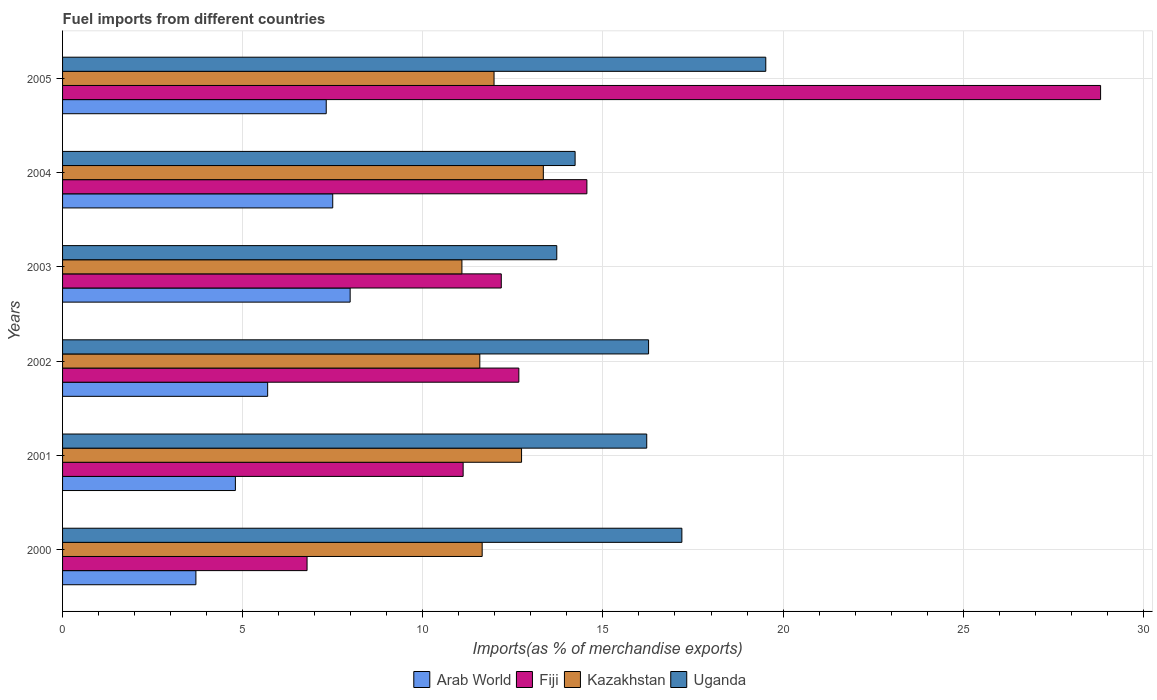How many bars are there on the 6th tick from the top?
Make the answer very short. 4. In how many cases, is the number of bars for a given year not equal to the number of legend labels?
Give a very brief answer. 0. What is the percentage of imports to different countries in Kazakhstan in 2002?
Give a very brief answer. 11.58. Across all years, what is the maximum percentage of imports to different countries in Uganda?
Your response must be concise. 19.52. Across all years, what is the minimum percentage of imports to different countries in Kazakhstan?
Make the answer very short. 11.09. In which year was the percentage of imports to different countries in Fiji maximum?
Make the answer very short. 2005. What is the total percentage of imports to different countries in Fiji in the graph?
Provide a succinct answer. 86.12. What is the difference between the percentage of imports to different countries in Arab World in 2000 and that in 2002?
Offer a terse response. -1.99. What is the difference between the percentage of imports to different countries in Uganda in 2004 and the percentage of imports to different countries in Kazakhstan in 2003?
Provide a succinct answer. 3.14. What is the average percentage of imports to different countries in Fiji per year?
Make the answer very short. 14.35. In the year 2004, what is the difference between the percentage of imports to different countries in Fiji and percentage of imports to different countries in Arab World?
Provide a short and direct response. 7.05. In how many years, is the percentage of imports to different countries in Kazakhstan greater than 19 %?
Your answer should be compact. 0. What is the ratio of the percentage of imports to different countries in Fiji in 2001 to that in 2003?
Provide a succinct answer. 0.91. Is the percentage of imports to different countries in Uganda in 2001 less than that in 2005?
Keep it short and to the point. Yes. Is the difference between the percentage of imports to different countries in Fiji in 2003 and 2004 greater than the difference between the percentage of imports to different countries in Arab World in 2003 and 2004?
Ensure brevity in your answer.  No. What is the difference between the highest and the second highest percentage of imports to different countries in Fiji?
Offer a terse response. 14.26. What is the difference between the highest and the lowest percentage of imports to different countries in Arab World?
Your answer should be compact. 4.28. In how many years, is the percentage of imports to different countries in Uganda greater than the average percentage of imports to different countries in Uganda taken over all years?
Provide a short and direct response. 4. Is the sum of the percentage of imports to different countries in Kazakhstan in 2000 and 2001 greater than the maximum percentage of imports to different countries in Arab World across all years?
Your answer should be very brief. Yes. Is it the case that in every year, the sum of the percentage of imports to different countries in Uganda and percentage of imports to different countries in Fiji is greater than the sum of percentage of imports to different countries in Arab World and percentage of imports to different countries in Kazakhstan?
Keep it short and to the point. Yes. What does the 1st bar from the top in 2005 represents?
Your answer should be compact. Uganda. What does the 2nd bar from the bottom in 2003 represents?
Your answer should be compact. Fiji. Is it the case that in every year, the sum of the percentage of imports to different countries in Fiji and percentage of imports to different countries in Uganda is greater than the percentage of imports to different countries in Arab World?
Your response must be concise. Yes. What is the difference between two consecutive major ticks on the X-axis?
Provide a succinct answer. 5. Are the values on the major ticks of X-axis written in scientific E-notation?
Your response must be concise. No. Does the graph contain any zero values?
Give a very brief answer. No. Does the graph contain grids?
Ensure brevity in your answer.  Yes. How many legend labels are there?
Provide a short and direct response. 4. What is the title of the graph?
Provide a succinct answer. Fuel imports from different countries. Does "Dominica" appear as one of the legend labels in the graph?
Provide a short and direct response. No. What is the label or title of the X-axis?
Ensure brevity in your answer.  Imports(as % of merchandise exports). What is the Imports(as % of merchandise exports) of Arab World in 2000?
Give a very brief answer. 3.7. What is the Imports(as % of merchandise exports) of Fiji in 2000?
Offer a terse response. 6.79. What is the Imports(as % of merchandise exports) of Kazakhstan in 2000?
Make the answer very short. 11.65. What is the Imports(as % of merchandise exports) in Uganda in 2000?
Your answer should be compact. 17.19. What is the Imports(as % of merchandise exports) in Arab World in 2001?
Your answer should be compact. 4.8. What is the Imports(as % of merchandise exports) in Fiji in 2001?
Offer a terse response. 11.12. What is the Imports(as % of merchandise exports) in Kazakhstan in 2001?
Provide a short and direct response. 12.74. What is the Imports(as % of merchandise exports) in Uganda in 2001?
Your response must be concise. 16.22. What is the Imports(as % of merchandise exports) of Arab World in 2002?
Your answer should be compact. 5.69. What is the Imports(as % of merchandise exports) in Fiji in 2002?
Ensure brevity in your answer.  12.67. What is the Imports(as % of merchandise exports) of Kazakhstan in 2002?
Provide a short and direct response. 11.58. What is the Imports(as % of merchandise exports) of Uganda in 2002?
Offer a very short reply. 16.27. What is the Imports(as % of merchandise exports) in Arab World in 2003?
Give a very brief answer. 7.98. What is the Imports(as % of merchandise exports) in Fiji in 2003?
Give a very brief answer. 12.18. What is the Imports(as % of merchandise exports) in Kazakhstan in 2003?
Provide a succinct answer. 11.09. What is the Imports(as % of merchandise exports) of Uganda in 2003?
Your answer should be very brief. 13.72. What is the Imports(as % of merchandise exports) of Arab World in 2004?
Keep it short and to the point. 7.5. What is the Imports(as % of merchandise exports) in Fiji in 2004?
Provide a short and direct response. 14.55. What is the Imports(as % of merchandise exports) of Kazakhstan in 2004?
Your response must be concise. 13.35. What is the Imports(as % of merchandise exports) of Uganda in 2004?
Make the answer very short. 14.23. What is the Imports(as % of merchandise exports) in Arab World in 2005?
Ensure brevity in your answer.  7.32. What is the Imports(as % of merchandise exports) in Fiji in 2005?
Your response must be concise. 28.81. What is the Imports(as % of merchandise exports) in Kazakhstan in 2005?
Give a very brief answer. 11.98. What is the Imports(as % of merchandise exports) in Uganda in 2005?
Provide a succinct answer. 19.52. Across all years, what is the maximum Imports(as % of merchandise exports) in Arab World?
Your response must be concise. 7.98. Across all years, what is the maximum Imports(as % of merchandise exports) of Fiji?
Your response must be concise. 28.81. Across all years, what is the maximum Imports(as % of merchandise exports) in Kazakhstan?
Provide a succinct answer. 13.35. Across all years, what is the maximum Imports(as % of merchandise exports) in Uganda?
Your response must be concise. 19.52. Across all years, what is the minimum Imports(as % of merchandise exports) in Arab World?
Keep it short and to the point. 3.7. Across all years, what is the minimum Imports(as % of merchandise exports) in Fiji?
Make the answer very short. 6.79. Across all years, what is the minimum Imports(as % of merchandise exports) in Kazakhstan?
Give a very brief answer. 11.09. Across all years, what is the minimum Imports(as % of merchandise exports) of Uganda?
Provide a short and direct response. 13.72. What is the total Imports(as % of merchandise exports) of Arab World in the graph?
Provide a short and direct response. 36.99. What is the total Imports(as % of merchandise exports) of Fiji in the graph?
Provide a short and direct response. 86.12. What is the total Imports(as % of merchandise exports) in Kazakhstan in the graph?
Offer a terse response. 72.38. What is the total Imports(as % of merchandise exports) of Uganda in the graph?
Keep it short and to the point. 97.14. What is the difference between the Imports(as % of merchandise exports) in Arab World in 2000 and that in 2001?
Give a very brief answer. -1.1. What is the difference between the Imports(as % of merchandise exports) of Fiji in 2000 and that in 2001?
Keep it short and to the point. -4.33. What is the difference between the Imports(as % of merchandise exports) of Kazakhstan in 2000 and that in 2001?
Provide a short and direct response. -1.09. What is the difference between the Imports(as % of merchandise exports) in Uganda in 2000 and that in 2001?
Your response must be concise. 0.98. What is the difference between the Imports(as % of merchandise exports) in Arab World in 2000 and that in 2002?
Your answer should be compact. -1.99. What is the difference between the Imports(as % of merchandise exports) of Fiji in 2000 and that in 2002?
Your answer should be compact. -5.88. What is the difference between the Imports(as % of merchandise exports) in Kazakhstan in 2000 and that in 2002?
Your answer should be very brief. 0.07. What is the difference between the Imports(as % of merchandise exports) in Uganda in 2000 and that in 2002?
Provide a succinct answer. 0.92. What is the difference between the Imports(as % of merchandise exports) of Arab World in 2000 and that in 2003?
Keep it short and to the point. -4.28. What is the difference between the Imports(as % of merchandise exports) of Fiji in 2000 and that in 2003?
Your answer should be compact. -5.39. What is the difference between the Imports(as % of merchandise exports) of Kazakhstan in 2000 and that in 2003?
Your answer should be compact. 0.56. What is the difference between the Imports(as % of merchandise exports) in Uganda in 2000 and that in 2003?
Provide a short and direct response. 3.47. What is the difference between the Imports(as % of merchandise exports) of Arab World in 2000 and that in 2004?
Ensure brevity in your answer.  -3.8. What is the difference between the Imports(as % of merchandise exports) in Fiji in 2000 and that in 2004?
Your response must be concise. -7.77. What is the difference between the Imports(as % of merchandise exports) in Kazakhstan in 2000 and that in 2004?
Provide a succinct answer. -1.7. What is the difference between the Imports(as % of merchandise exports) in Uganda in 2000 and that in 2004?
Your answer should be compact. 2.96. What is the difference between the Imports(as % of merchandise exports) of Arab World in 2000 and that in 2005?
Offer a terse response. -3.62. What is the difference between the Imports(as % of merchandise exports) in Fiji in 2000 and that in 2005?
Provide a succinct answer. -22.03. What is the difference between the Imports(as % of merchandise exports) in Kazakhstan in 2000 and that in 2005?
Your answer should be very brief. -0.33. What is the difference between the Imports(as % of merchandise exports) of Uganda in 2000 and that in 2005?
Offer a very short reply. -2.33. What is the difference between the Imports(as % of merchandise exports) of Arab World in 2001 and that in 2002?
Offer a terse response. -0.9. What is the difference between the Imports(as % of merchandise exports) in Fiji in 2001 and that in 2002?
Provide a succinct answer. -1.55. What is the difference between the Imports(as % of merchandise exports) in Kazakhstan in 2001 and that in 2002?
Keep it short and to the point. 1.16. What is the difference between the Imports(as % of merchandise exports) in Uganda in 2001 and that in 2002?
Your answer should be very brief. -0.05. What is the difference between the Imports(as % of merchandise exports) of Arab World in 2001 and that in 2003?
Offer a very short reply. -3.19. What is the difference between the Imports(as % of merchandise exports) in Fiji in 2001 and that in 2003?
Your answer should be compact. -1.06. What is the difference between the Imports(as % of merchandise exports) in Kazakhstan in 2001 and that in 2003?
Your answer should be very brief. 1.66. What is the difference between the Imports(as % of merchandise exports) in Uganda in 2001 and that in 2003?
Provide a succinct answer. 2.5. What is the difference between the Imports(as % of merchandise exports) in Arab World in 2001 and that in 2004?
Your answer should be compact. -2.7. What is the difference between the Imports(as % of merchandise exports) in Fiji in 2001 and that in 2004?
Your answer should be compact. -3.44. What is the difference between the Imports(as % of merchandise exports) of Kazakhstan in 2001 and that in 2004?
Keep it short and to the point. -0.6. What is the difference between the Imports(as % of merchandise exports) in Uganda in 2001 and that in 2004?
Your answer should be very brief. 1.99. What is the difference between the Imports(as % of merchandise exports) in Arab World in 2001 and that in 2005?
Offer a very short reply. -2.52. What is the difference between the Imports(as % of merchandise exports) in Fiji in 2001 and that in 2005?
Give a very brief answer. -17.69. What is the difference between the Imports(as % of merchandise exports) in Kazakhstan in 2001 and that in 2005?
Your answer should be compact. 0.76. What is the difference between the Imports(as % of merchandise exports) of Uganda in 2001 and that in 2005?
Your answer should be compact. -3.3. What is the difference between the Imports(as % of merchandise exports) of Arab World in 2002 and that in 2003?
Your answer should be very brief. -2.29. What is the difference between the Imports(as % of merchandise exports) of Fiji in 2002 and that in 2003?
Offer a very short reply. 0.49. What is the difference between the Imports(as % of merchandise exports) in Kazakhstan in 2002 and that in 2003?
Ensure brevity in your answer.  0.5. What is the difference between the Imports(as % of merchandise exports) in Uganda in 2002 and that in 2003?
Make the answer very short. 2.55. What is the difference between the Imports(as % of merchandise exports) of Arab World in 2002 and that in 2004?
Your answer should be very brief. -1.81. What is the difference between the Imports(as % of merchandise exports) in Fiji in 2002 and that in 2004?
Your answer should be compact. -1.89. What is the difference between the Imports(as % of merchandise exports) in Kazakhstan in 2002 and that in 2004?
Your response must be concise. -1.76. What is the difference between the Imports(as % of merchandise exports) of Uganda in 2002 and that in 2004?
Provide a succinct answer. 2.04. What is the difference between the Imports(as % of merchandise exports) in Arab World in 2002 and that in 2005?
Offer a terse response. -1.63. What is the difference between the Imports(as % of merchandise exports) in Fiji in 2002 and that in 2005?
Offer a very short reply. -16.15. What is the difference between the Imports(as % of merchandise exports) in Kazakhstan in 2002 and that in 2005?
Provide a succinct answer. -0.4. What is the difference between the Imports(as % of merchandise exports) of Uganda in 2002 and that in 2005?
Your answer should be very brief. -3.25. What is the difference between the Imports(as % of merchandise exports) in Arab World in 2003 and that in 2004?
Your answer should be compact. 0.48. What is the difference between the Imports(as % of merchandise exports) in Fiji in 2003 and that in 2004?
Provide a succinct answer. -2.38. What is the difference between the Imports(as % of merchandise exports) of Kazakhstan in 2003 and that in 2004?
Provide a short and direct response. -2.26. What is the difference between the Imports(as % of merchandise exports) of Uganda in 2003 and that in 2004?
Ensure brevity in your answer.  -0.51. What is the difference between the Imports(as % of merchandise exports) in Arab World in 2003 and that in 2005?
Your answer should be compact. 0.66. What is the difference between the Imports(as % of merchandise exports) in Fiji in 2003 and that in 2005?
Ensure brevity in your answer.  -16.64. What is the difference between the Imports(as % of merchandise exports) of Kazakhstan in 2003 and that in 2005?
Provide a short and direct response. -0.89. What is the difference between the Imports(as % of merchandise exports) in Uganda in 2003 and that in 2005?
Offer a very short reply. -5.8. What is the difference between the Imports(as % of merchandise exports) in Arab World in 2004 and that in 2005?
Provide a short and direct response. 0.18. What is the difference between the Imports(as % of merchandise exports) in Fiji in 2004 and that in 2005?
Offer a very short reply. -14.26. What is the difference between the Imports(as % of merchandise exports) in Kazakhstan in 2004 and that in 2005?
Keep it short and to the point. 1.37. What is the difference between the Imports(as % of merchandise exports) in Uganda in 2004 and that in 2005?
Your response must be concise. -5.29. What is the difference between the Imports(as % of merchandise exports) of Arab World in 2000 and the Imports(as % of merchandise exports) of Fiji in 2001?
Ensure brevity in your answer.  -7.42. What is the difference between the Imports(as % of merchandise exports) of Arab World in 2000 and the Imports(as % of merchandise exports) of Kazakhstan in 2001?
Keep it short and to the point. -9.04. What is the difference between the Imports(as % of merchandise exports) in Arab World in 2000 and the Imports(as % of merchandise exports) in Uganda in 2001?
Provide a succinct answer. -12.51. What is the difference between the Imports(as % of merchandise exports) in Fiji in 2000 and the Imports(as % of merchandise exports) in Kazakhstan in 2001?
Your answer should be compact. -5.95. What is the difference between the Imports(as % of merchandise exports) of Fiji in 2000 and the Imports(as % of merchandise exports) of Uganda in 2001?
Your answer should be very brief. -9.43. What is the difference between the Imports(as % of merchandise exports) of Kazakhstan in 2000 and the Imports(as % of merchandise exports) of Uganda in 2001?
Ensure brevity in your answer.  -4.57. What is the difference between the Imports(as % of merchandise exports) of Arab World in 2000 and the Imports(as % of merchandise exports) of Fiji in 2002?
Give a very brief answer. -8.96. What is the difference between the Imports(as % of merchandise exports) of Arab World in 2000 and the Imports(as % of merchandise exports) of Kazakhstan in 2002?
Offer a very short reply. -7.88. What is the difference between the Imports(as % of merchandise exports) of Arab World in 2000 and the Imports(as % of merchandise exports) of Uganda in 2002?
Provide a short and direct response. -12.57. What is the difference between the Imports(as % of merchandise exports) in Fiji in 2000 and the Imports(as % of merchandise exports) in Kazakhstan in 2002?
Offer a terse response. -4.8. What is the difference between the Imports(as % of merchandise exports) of Fiji in 2000 and the Imports(as % of merchandise exports) of Uganda in 2002?
Offer a terse response. -9.48. What is the difference between the Imports(as % of merchandise exports) in Kazakhstan in 2000 and the Imports(as % of merchandise exports) in Uganda in 2002?
Your answer should be very brief. -4.62. What is the difference between the Imports(as % of merchandise exports) of Arab World in 2000 and the Imports(as % of merchandise exports) of Fiji in 2003?
Your answer should be very brief. -8.48. What is the difference between the Imports(as % of merchandise exports) of Arab World in 2000 and the Imports(as % of merchandise exports) of Kazakhstan in 2003?
Your response must be concise. -7.38. What is the difference between the Imports(as % of merchandise exports) of Arab World in 2000 and the Imports(as % of merchandise exports) of Uganda in 2003?
Ensure brevity in your answer.  -10.02. What is the difference between the Imports(as % of merchandise exports) in Fiji in 2000 and the Imports(as % of merchandise exports) in Kazakhstan in 2003?
Offer a very short reply. -4.3. What is the difference between the Imports(as % of merchandise exports) of Fiji in 2000 and the Imports(as % of merchandise exports) of Uganda in 2003?
Provide a succinct answer. -6.93. What is the difference between the Imports(as % of merchandise exports) in Kazakhstan in 2000 and the Imports(as % of merchandise exports) in Uganda in 2003?
Provide a succinct answer. -2.07. What is the difference between the Imports(as % of merchandise exports) in Arab World in 2000 and the Imports(as % of merchandise exports) in Fiji in 2004?
Give a very brief answer. -10.85. What is the difference between the Imports(as % of merchandise exports) in Arab World in 2000 and the Imports(as % of merchandise exports) in Kazakhstan in 2004?
Ensure brevity in your answer.  -9.64. What is the difference between the Imports(as % of merchandise exports) of Arab World in 2000 and the Imports(as % of merchandise exports) of Uganda in 2004?
Your response must be concise. -10.53. What is the difference between the Imports(as % of merchandise exports) of Fiji in 2000 and the Imports(as % of merchandise exports) of Kazakhstan in 2004?
Your response must be concise. -6.56. What is the difference between the Imports(as % of merchandise exports) of Fiji in 2000 and the Imports(as % of merchandise exports) of Uganda in 2004?
Offer a very short reply. -7.44. What is the difference between the Imports(as % of merchandise exports) in Kazakhstan in 2000 and the Imports(as % of merchandise exports) in Uganda in 2004?
Provide a succinct answer. -2.58. What is the difference between the Imports(as % of merchandise exports) in Arab World in 2000 and the Imports(as % of merchandise exports) in Fiji in 2005?
Offer a terse response. -25.11. What is the difference between the Imports(as % of merchandise exports) of Arab World in 2000 and the Imports(as % of merchandise exports) of Kazakhstan in 2005?
Provide a succinct answer. -8.28. What is the difference between the Imports(as % of merchandise exports) in Arab World in 2000 and the Imports(as % of merchandise exports) in Uganda in 2005?
Your response must be concise. -15.82. What is the difference between the Imports(as % of merchandise exports) of Fiji in 2000 and the Imports(as % of merchandise exports) of Kazakhstan in 2005?
Give a very brief answer. -5.19. What is the difference between the Imports(as % of merchandise exports) of Fiji in 2000 and the Imports(as % of merchandise exports) of Uganda in 2005?
Offer a very short reply. -12.73. What is the difference between the Imports(as % of merchandise exports) of Kazakhstan in 2000 and the Imports(as % of merchandise exports) of Uganda in 2005?
Provide a succinct answer. -7.87. What is the difference between the Imports(as % of merchandise exports) in Arab World in 2001 and the Imports(as % of merchandise exports) in Fiji in 2002?
Provide a succinct answer. -7.87. What is the difference between the Imports(as % of merchandise exports) in Arab World in 2001 and the Imports(as % of merchandise exports) in Kazakhstan in 2002?
Make the answer very short. -6.78. What is the difference between the Imports(as % of merchandise exports) in Arab World in 2001 and the Imports(as % of merchandise exports) in Uganda in 2002?
Give a very brief answer. -11.47. What is the difference between the Imports(as % of merchandise exports) of Fiji in 2001 and the Imports(as % of merchandise exports) of Kazakhstan in 2002?
Your answer should be compact. -0.46. What is the difference between the Imports(as % of merchandise exports) in Fiji in 2001 and the Imports(as % of merchandise exports) in Uganda in 2002?
Ensure brevity in your answer.  -5.15. What is the difference between the Imports(as % of merchandise exports) of Kazakhstan in 2001 and the Imports(as % of merchandise exports) of Uganda in 2002?
Give a very brief answer. -3.53. What is the difference between the Imports(as % of merchandise exports) of Arab World in 2001 and the Imports(as % of merchandise exports) of Fiji in 2003?
Offer a very short reply. -7.38. What is the difference between the Imports(as % of merchandise exports) of Arab World in 2001 and the Imports(as % of merchandise exports) of Kazakhstan in 2003?
Give a very brief answer. -6.29. What is the difference between the Imports(as % of merchandise exports) of Arab World in 2001 and the Imports(as % of merchandise exports) of Uganda in 2003?
Make the answer very short. -8.92. What is the difference between the Imports(as % of merchandise exports) of Fiji in 2001 and the Imports(as % of merchandise exports) of Kazakhstan in 2003?
Give a very brief answer. 0.03. What is the difference between the Imports(as % of merchandise exports) of Fiji in 2001 and the Imports(as % of merchandise exports) of Uganda in 2003?
Offer a terse response. -2.6. What is the difference between the Imports(as % of merchandise exports) in Kazakhstan in 2001 and the Imports(as % of merchandise exports) in Uganda in 2003?
Your answer should be compact. -0.98. What is the difference between the Imports(as % of merchandise exports) of Arab World in 2001 and the Imports(as % of merchandise exports) of Fiji in 2004?
Give a very brief answer. -9.76. What is the difference between the Imports(as % of merchandise exports) in Arab World in 2001 and the Imports(as % of merchandise exports) in Kazakhstan in 2004?
Give a very brief answer. -8.55. What is the difference between the Imports(as % of merchandise exports) in Arab World in 2001 and the Imports(as % of merchandise exports) in Uganda in 2004?
Your answer should be very brief. -9.43. What is the difference between the Imports(as % of merchandise exports) of Fiji in 2001 and the Imports(as % of merchandise exports) of Kazakhstan in 2004?
Ensure brevity in your answer.  -2.23. What is the difference between the Imports(as % of merchandise exports) of Fiji in 2001 and the Imports(as % of merchandise exports) of Uganda in 2004?
Offer a terse response. -3.11. What is the difference between the Imports(as % of merchandise exports) in Kazakhstan in 2001 and the Imports(as % of merchandise exports) in Uganda in 2004?
Offer a very short reply. -1.49. What is the difference between the Imports(as % of merchandise exports) in Arab World in 2001 and the Imports(as % of merchandise exports) in Fiji in 2005?
Offer a terse response. -24.02. What is the difference between the Imports(as % of merchandise exports) of Arab World in 2001 and the Imports(as % of merchandise exports) of Kazakhstan in 2005?
Your response must be concise. -7.18. What is the difference between the Imports(as % of merchandise exports) in Arab World in 2001 and the Imports(as % of merchandise exports) in Uganda in 2005?
Provide a succinct answer. -14.72. What is the difference between the Imports(as % of merchandise exports) of Fiji in 2001 and the Imports(as % of merchandise exports) of Kazakhstan in 2005?
Provide a short and direct response. -0.86. What is the difference between the Imports(as % of merchandise exports) in Fiji in 2001 and the Imports(as % of merchandise exports) in Uganda in 2005?
Make the answer very short. -8.4. What is the difference between the Imports(as % of merchandise exports) in Kazakhstan in 2001 and the Imports(as % of merchandise exports) in Uganda in 2005?
Make the answer very short. -6.78. What is the difference between the Imports(as % of merchandise exports) of Arab World in 2002 and the Imports(as % of merchandise exports) of Fiji in 2003?
Provide a short and direct response. -6.49. What is the difference between the Imports(as % of merchandise exports) in Arab World in 2002 and the Imports(as % of merchandise exports) in Kazakhstan in 2003?
Make the answer very short. -5.39. What is the difference between the Imports(as % of merchandise exports) in Arab World in 2002 and the Imports(as % of merchandise exports) in Uganda in 2003?
Ensure brevity in your answer.  -8.03. What is the difference between the Imports(as % of merchandise exports) in Fiji in 2002 and the Imports(as % of merchandise exports) in Kazakhstan in 2003?
Provide a short and direct response. 1.58. What is the difference between the Imports(as % of merchandise exports) in Fiji in 2002 and the Imports(as % of merchandise exports) in Uganda in 2003?
Your answer should be very brief. -1.05. What is the difference between the Imports(as % of merchandise exports) in Kazakhstan in 2002 and the Imports(as % of merchandise exports) in Uganda in 2003?
Keep it short and to the point. -2.14. What is the difference between the Imports(as % of merchandise exports) in Arab World in 2002 and the Imports(as % of merchandise exports) in Fiji in 2004?
Provide a short and direct response. -8.86. What is the difference between the Imports(as % of merchandise exports) of Arab World in 2002 and the Imports(as % of merchandise exports) of Kazakhstan in 2004?
Provide a succinct answer. -7.65. What is the difference between the Imports(as % of merchandise exports) in Arab World in 2002 and the Imports(as % of merchandise exports) in Uganda in 2004?
Your answer should be very brief. -8.53. What is the difference between the Imports(as % of merchandise exports) in Fiji in 2002 and the Imports(as % of merchandise exports) in Kazakhstan in 2004?
Keep it short and to the point. -0.68. What is the difference between the Imports(as % of merchandise exports) in Fiji in 2002 and the Imports(as % of merchandise exports) in Uganda in 2004?
Your response must be concise. -1.56. What is the difference between the Imports(as % of merchandise exports) of Kazakhstan in 2002 and the Imports(as % of merchandise exports) of Uganda in 2004?
Your answer should be very brief. -2.65. What is the difference between the Imports(as % of merchandise exports) of Arab World in 2002 and the Imports(as % of merchandise exports) of Fiji in 2005?
Make the answer very short. -23.12. What is the difference between the Imports(as % of merchandise exports) in Arab World in 2002 and the Imports(as % of merchandise exports) in Kazakhstan in 2005?
Your answer should be compact. -6.28. What is the difference between the Imports(as % of merchandise exports) of Arab World in 2002 and the Imports(as % of merchandise exports) of Uganda in 2005?
Ensure brevity in your answer.  -13.83. What is the difference between the Imports(as % of merchandise exports) of Fiji in 2002 and the Imports(as % of merchandise exports) of Kazakhstan in 2005?
Keep it short and to the point. 0.69. What is the difference between the Imports(as % of merchandise exports) of Fiji in 2002 and the Imports(as % of merchandise exports) of Uganda in 2005?
Make the answer very short. -6.85. What is the difference between the Imports(as % of merchandise exports) of Kazakhstan in 2002 and the Imports(as % of merchandise exports) of Uganda in 2005?
Give a very brief answer. -7.94. What is the difference between the Imports(as % of merchandise exports) of Arab World in 2003 and the Imports(as % of merchandise exports) of Fiji in 2004?
Keep it short and to the point. -6.57. What is the difference between the Imports(as % of merchandise exports) of Arab World in 2003 and the Imports(as % of merchandise exports) of Kazakhstan in 2004?
Your answer should be compact. -5.36. What is the difference between the Imports(as % of merchandise exports) in Arab World in 2003 and the Imports(as % of merchandise exports) in Uganda in 2004?
Make the answer very short. -6.24. What is the difference between the Imports(as % of merchandise exports) in Fiji in 2003 and the Imports(as % of merchandise exports) in Kazakhstan in 2004?
Your answer should be compact. -1.17. What is the difference between the Imports(as % of merchandise exports) in Fiji in 2003 and the Imports(as % of merchandise exports) in Uganda in 2004?
Make the answer very short. -2.05. What is the difference between the Imports(as % of merchandise exports) of Kazakhstan in 2003 and the Imports(as % of merchandise exports) of Uganda in 2004?
Provide a succinct answer. -3.14. What is the difference between the Imports(as % of merchandise exports) of Arab World in 2003 and the Imports(as % of merchandise exports) of Fiji in 2005?
Keep it short and to the point. -20.83. What is the difference between the Imports(as % of merchandise exports) in Arab World in 2003 and the Imports(as % of merchandise exports) in Kazakhstan in 2005?
Your response must be concise. -3.99. What is the difference between the Imports(as % of merchandise exports) in Arab World in 2003 and the Imports(as % of merchandise exports) in Uganda in 2005?
Ensure brevity in your answer.  -11.54. What is the difference between the Imports(as % of merchandise exports) in Fiji in 2003 and the Imports(as % of merchandise exports) in Kazakhstan in 2005?
Your answer should be very brief. 0.2. What is the difference between the Imports(as % of merchandise exports) of Fiji in 2003 and the Imports(as % of merchandise exports) of Uganda in 2005?
Offer a terse response. -7.34. What is the difference between the Imports(as % of merchandise exports) in Kazakhstan in 2003 and the Imports(as % of merchandise exports) in Uganda in 2005?
Give a very brief answer. -8.43. What is the difference between the Imports(as % of merchandise exports) of Arab World in 2004 and the Imports(as % of merchandise exports) of Fiji in 2005?
Provide a succinct answer. -21.31. What is the difference between the Imports(as % of merchandise exports) of Arab World in 2004 and the Imports(as % of merchandise exports) of Kazakhstan in 2005?
Your answer should be very brief. -4.48. What is the difference between the Imports(as % of merchandise exports) of Arab World in 2004 and the Imports(as % of merchandise exports) of Uganda in 2005?
Offer a very short reply. -12.02. What is the difference between the Imports(as % of merchandise exports) of Fiji in 2004 and the Imports(as % of merchandise exports) of Kazakhstan in 2005?
Provide a succinct answer. 2.58. What is the difference between the Imports(as % of merchandise exports) in Fiji in 2004 and the Imports(as % of merchandise exports) in Uganda in 2005?
Your answer should be very brief. -4.97. What is the difference between the Imports(as % of merchandise exports) of Kazakhstan in 2004 and the Imports(as % of merchandise exports) of Uganda in 2005?
Give a very brief answer. -6.17. What is the average Imports(as % of merchandise exports) in Arab World per year?
Your answer should be compact. 6.17. What is the average Imports(as % of merchandise exports) of Fiji per year?
Offer a very short reply. 14.35. What is the average Imports(as % of merchandise exports) in Kazakhstan per year?
Ensure brevity in your answer.  12.06. What is the average Imports(as % of merchandise exports) in Uganda per year?
Offer a very short reply. 16.19. In the year 2000, what is the difference between the Imports(as % of merchandise exports) of Arab World and Imports(as % of merchandise exports) of Fiji?
Provide a short and direct response. -3.09. In the year 2000, what is the difference between the Imports(as % of merchandise exports) in Arab World and Imports(as % of merchandise exports) in Kazakhstan?
Your answer should be compact. -7.95. In the year 2000, what is the difference between the Imports(as % of merchandise exports) in Arab World and Imports(as % of merchandise exports) in Uganda?
Make the answer very short. -13.49. In the year 2000, what is the difference between the Imports(as % of merchandise exports) in Fiji and Imports(as % of merchandise exports) in Kazakhstan?
Keep it short and to the point. -4.86. In the year 2000, what is the difference between the Imports(as % of merchandise exports) of Fiji and Imports(as % of merchandise exports) of Uganda?
Provide a succinct answer. -10.4. In the year 2000, what is the difference between the Imports(as % of merchandise exports) of Kazakhstan and Imports(as % of merchandise exports) of Uganda?
Your answer should be very brief. -5.54. In the year 2001, what is the difference between the Imports(as % of merchandise exports) in Arab World and Imports(as % of merchandise exports) in Fiji?
Your response must be concise. -6.32. In the year 2001, what is the difference between the Imports(as % of merchandise exports) of Arab World and Imports(as % of merchandise exports) of Kazakhstan?
Give a very brief answer. -7.94. In the year 2001, what is the difference between the Imports(as % of merchandise exports) in Arab World and Imports(as % of merchandise exports) in Uganda?
Your answer should be compact. -11.42. In the year 2001, what is the difference between the Imports(as % of merchandise exports) in Fiji and Imports(as % of merchandise exports) in Kazakhstan?
Your response must be concise. -1.62. In the year 2001, what is the difference between the Imports(as % of merchandise exports) in Fiji and Imports(as % of merchandise exports) in Uganda?
Your answer should be compact. -5.1. In the year 2001, what is the difference between the Imports(as % of merchandise exports) of Kazakhstan and Imports(as % of merchandise exports) of Uganda?
Your answer should be very brief. -3.47. In the year 2002, what is the difference between the Imports(as % of merchandise exports) of Arab World and Imports(as % of merchandise exports) of Fiji?
Give a very brief answer. -6.97. In the year 2002, what is the difference between the Imports(as % of merchandise exports) of Arab World and Imports(as % of merchandise exports) of Kazakhstan?
Your answer should be compact. -5.89. In the year 2002, what is the difference between the Imports(as % of merchandise exports) of Arab World and Imports(as % of merchandise exports) of Uganda?
Your response must be concise. -10.57. In the year 2002, what is the difference between the Imports(as % of merchandise exports) in Fiji and Imports(as % of merchandise exports) in Kazakhstan?
Your answer should be compact. 1.08. In the year 2002, what is the difference between the Imports(as % of merchandise exports) in Fiji and Imports(as % of merchandise exports) in Uganda?
Give a very brief answer. -3.6. In the year 2002, what is the difference between the Imports(as % of merchandise exports) of Kazakhstan and Imports(as % of merchandise exports) of Uganda?
Give a very brief answer. -4.68. In the year 2003, what is the difference between the Imports(as % of merchandise exports) in Arab World and Imports(as % of merchandise exports) in Fiji?
Your answer should be very brief. -4.19. In the year 2003, what is the difference between the Imports(as % of merchandise exports) in Arab World and Imports(as % of merchandise exports) in Kazakhstan?
Provide a short and direct response. -3.1. In the year 2003, what is the difference between the Imports(as % of merchandise exports) in Arab World and Imports(as % of merchandise exports) in Uganda?
Keep it short and to the point. -5.74. In the year 2003, what is the difference between the Imports(as % of merchandise exports) of Fiji and Imports(as % of merchandise exports) of Kazakhstan?
Offer a very short reply. 1.09. In the year 2003, what is the difference between the Imports(as % of merchandise exports) in Fiji and Imports(as % of merchandise exports) in Uganda?
Provide a succinct answer. -1.54. In the year 2003, what is the difference between the Imports(as % of merchandise exports) of Kazakhstan and Imports(as % of merchandise exports) of Uganda?
Offer a very short reply. -2.63. In the year 2004, what is the difference between the Imports(as % of merchandise exports) of Arab World and Imports(as % of merchandise exports) of Fiji?
Give a very brief answer. -7.05. In the year 2004, what is the difference between the Imports(as % of merchandise exports) of Arab World and Imports(as % of merchandise exports) of Kazakhstan?
Your answer should be very brief. -5.85. In the year 2004, what is the difference between the Imports(as % of merchandise exports) in Arab World and Imports(as % of merchandise exports) in Uganda?
Your answer should be very brief. -6.73. In the year 2004, what is the difference between the Imports(as % of merchandise exports) of Fiji and Imports(as % of merchandise exports) of Kazakhstan?
Give a very brief answer. 1.21. In the year 2004, what is the difference between the Imports(as % of merchandise exports) in Fiji and Imports(as % of merchandise exports) in Uganda?
Keep it short and to the point. 0.33. In the year 2004, what is the difference between the Imports(as % of merchandise exports) in Kazakhstan and Imports(as % of merchandise exports) in Uganda?
Ensure brevity in your answer.  -0.88. In the year 2005, what is the difference between the Imports(as % of merchandise exports) in Arab World and Imports(as % of merchandise exports) in Fiji?
Make the answer very short. -21.5. In the year 2005, what is the difference between the Imports(as % of merchandise exports) in Arab World and Imports(as % of merchandise exports) in Kazakhstan?
Your answer should be compact. -4.66. In the year 2005, what is the difference between the Imports(as % of merchandise exports) in Arab World and Imports(as % of merchandise exports) in Uganda?
Offer a very short reply. -12.2. In the year 2005, what is the difference between the Imports(as % of merchandise exports) in Fiji and Imports(as % of merchandise exports) in Kazakhstan?
Offer a terse response. 16.84. In the year 2005, what is the difference between the Imports(as % of merchandise exports) of Fiji and Imports(as % of merchandise exports) of Uganda?
Your answer should be very brief. 9.29. In the year 2005, what is the difference between the Imports(as % of merchandise exports) of Kazakhstan and Imports(as % of merchandise exports) of Uganda?
Your response must be concise. -7.54. What is the ratio of the Imports(as % of merchandise exports) of Arab World in 2000 to that in 2001?
Your answer should be compact. 0.77. What is the ratio of the Imports(as % of merchandise exports) of Fiji in 2000 to that in 2001?
Offer a very short reply. 0.61. What is the ratio of the Imports(as % of merchandise exports) of Kazakhstan in 2000 to that in 2001?
Ensure brevity in your answer.  0.91. What is the ratio of the Imports(as % of merchandise exports) of Uganda in 2000 to that in 2001?
Keep it short and to the point. 1.06. What is the ratio of the Imports(as % of merchandise exports) of Arab World in 2000 to that in 2002?
Offer a very short reply. 0.65. What is the ratio of the Imports(as % of merchandise exports) of Fiji in 2000 to that in 2002?
Your answer should be very brief. 0.54. What is the ratio of the Imports(as % of merchandise exports) in Uganda in 2000 to that in 2002?
Provide a short and direct response. 1.06. What is the ratio of the Imports(as % of merchandise exports) of Arab World in 2000 to that in 2003?
Give a very brief answer. 0.46. What is the ratio of the Imports(as % of merchandise exports) in Fiji in 2000 to that in 2003?
Offer a terse response. 0.56. What is the ratio of the Imports(as % of merchandise exports) in Kazakhstan in 2000 to that in 2003?
Your answer should be very brief. 1.05. What is the ratio of the Imports(as % of merchandise exports) in Uganda in 2000 to that in 2003?
Offer a very short reply. 1.25. What is the ratio of the Imports(as % of merchandise exports) in Arab World in 2000 to that in 2004?
Ensure brevity in your answer.  0.49. What is the ratio of the Imports(as % of merchandise exports) of Fiji in 2000 to that in 2004?
Your answer should be very brief. 0.47. What is the ratio of the Imports(as % of merchandise exports) of Kazakhstan in 2000 to that in 2004?
Provide a short and direct response. 0.87. What is the ratio of the Imports(as % of merchandise exports) of Uganda in 2000 to that in 2004?
Your answer should be very brief. 1.21. What is the ratio of the Imports(as % of merchandise exports) in Arab World in 2000 to that in 2005?
Provide a succinct answer. 0.51. What is the ratio of the Imports(as % of merchandise exports) in Fiji in 2000 to that in 2005?
Give a very brief answer. 0.24. What is the ratio of the Imports(as % of merchandise exports) in Kazakhstan in 2000 to that in 2005?
Give a very brief answer. 0.97. What is the ratio of the Imports(as % of merchandise exports) in Uganda in 2000 to that in 2005?
Offer a terse response. 0.88. What is the ratio of the Imports(as % of merchandise exports) of Arab World in 2001 to that in 2002?
Offer a very short reply. 0.84. What is the ratio of the Imports(as % of merchandise exports) in Fiji in 2001 to that in 2002?
Your response must be concise. 0.88. What is the ratio of the Imports(as % of merchandise exports) in Kazakhstan in 2001 to that in 2002?
Give a very brief answer. 1.1. What is the ratio of the Imports(as % of merchandise exports) in Arab World in 2001 to that in 2003?
Your response must be concise. 0.6. What is the ratio of the Imports(as % of merchandise exports) in Fiji in 2001 to that in 2003?
Provide a succinct answer. 0.91. What is the ratio of the Imports(as % of merchandise exports) of Kazakhstan in 2001 to that in 2003?
Your answer should be very brief. 1.15. What is the ratio of the Imports(as % of merchandise exports) of Uganda in 2001 to that in 2003?
Give a very brief answer. 1.18. What is the ratio of the Imports(as % of merchandise exports) of Arab World in 2001 to that in 2004?
Ensure brevity in your answer.  0.64. What is the ratio of the Imports(as % of merchandise exports) of Fiji in 2001 to that in 2004?
Provide a short and direct response. 0.76. What is the ratio of the Imports(as % of merchandise exports) of Kazakhstan in 2001 to that in 2004?
Provide a short and direct response. 0.95. What is the ratio of the Imports(as % of merchandise exports) in Uganda in 2001 to that in 2004?
Make the answer very short. 1.14. What is the ratio of the Imports(as % of merchandise exports) in Arab World in 2001 to that in 2005?
Offer a terse response. 0.66. What is the ratio of the Imports(as % of merchandise exports) in Fiji in 2001 to that in 2005?
Ensure brevity in your answer.  0.39. What is the ratio of the Imports(as % of merchandise exports) of Kazakhstan in 2001 to that in 2005?
Your response must be concise. 1.06. What is the ratio of the Imports(as % of merchandise exports) of Uganda in 2001 to that in 2005?
Make the answer very short. 0.83. What is the ratio of the Imports(as % of merchandise exports) in Arab World in 2002 to that in 2003?
Provide a short and direct response. 0.71. What is the ratio of the Imports(as % of merchandise exports) in Fiji in 2002 to that in 2003?
Your answer should be compact. 1.04. What is the ratio of the Imports(as % of merchandise exports) of Kazakhstan in 2002 to that in 2003?
Offer a very short reply. 1.04. What is the ratio of the Imports(as % of merchandise exports) of Uganda in 2002 to that in 2003?
Provide a succinct answer. 1.19. What is the ratio of the Imports(as % of merchandise exports) of Arab World in 2002 to that in 2004?
Offer a terse response. 0.76. What is the ratio of the Imports(as % of merchandise exports) of Fiji in 2002 to that in 2004?
Give a very brief answer. 0.87. What is the ratio of the Imports(as % of merchandise exports) in Kazakhstan in 2002 to that in 2004?
Ensure brevity in your answer.  0.87. What is the ratio of the Imports(as % of merchandise exports) of Uganda in 2002 to that in 2004?
Your answer should be very brief. 1.14. What is the ratio of the Imports(as % of merchandise exports) of Fiji in 2002 to that in 2005?
Offer a very short reply. 0.44. What is the ratio of the Imports(as % of merchandise exports) in Uganda in 2002 to that in 2005?
Give a very brief answer. 0.83. What is the ratio of the Imports(as % of merchandise exports) in Arab World in 2003 to that in 2004?
Keep it short and to the point. 1.06. What is the ratio of the Imports(as % of merchandise exports) of Fiji in 2003 to that in 2004?
Provide a short and direct response. 0.84. What is the ratio of the Imports(as % of merchandise exports) of Kazakhstan in 2003 to that in 2004?
Keep it short and to the point. 0.83. What is the ratio of the Imports(as % of merchandise exports) in Uganda in 2003 to that in 2004?
Your answer should be compact. 0.96. What is the ratio of the Imports(as % of merchandise exports) in Arab World in 2003 to that in 2005?
Your answer should be very brief. 1.09. What is the ratio of the Imports(as % of merchandise exports) of Fiji in 2003 to that in 2005?
Provide a short and direct response. 0.42. What is the ratio of the Imports(as % of merchandise exports) of Kazakhstan in 2003 to that in 2005?
Offer a terse response. 0.93. What is the ratio of the Imports(as % of merchandise exports) in Uganda in 2003 to that in 2005?
Your response must be concise. 0.7. What is the ratio of the Imports(as % of merchandise exports) in Arab World in 2004 to that in 2005?
Provide a succinct answer. 1.02. What is the ratio of the Imports(as % of merchandise exports) in Fiji in 2004 to that in 2005?
Your response must be concise. 0.51. What is the ratio of the Imports(as % of merchandise exports) in Kazakhstan in 2004 to that in 2005?
Your answer should be compact. 1.11. What is the ratio of the Imports(as % of merchandise exports) in Uganda in 2004 to that in 2005?
Ensure brevity in your answer.  0.73. What is the difference between the highest and the second highest Imports(as % of merchandise exports) in Arab World?
Offer a terse response. 0.48. What is the difference between the highest and the second highest Imports(as % of merchandise exports) of Fiji?
Keep it short and to the point. 14.26. What is the difference between the highest and the second highest Imports(as % of merchandise exports) in Kazakhstan?
Provide a succinct answer. 0.6. What is the difference between the highest and the second highest Imports(as % of merchandise exports) in Uganda?
Give a very brief answer. 2.33. What is the difference between the highest and the lowest Imports(as % of merchandise exports) in Arab World?
Offer a terse response. 4.28. What is the difference between the highest and the lowest Imports(as % of merchandise exports) in Fiji?
Ensure brevity in your answer.  22.03. What is the difference between the highest and the lowest Imports(as % of merchandise exports) in Kazakhstan?
Ensure brevity in your answer.  2.26. What is the difference between the highest and the lowest Imports(as % of merchandise exports) in Uganda?
Provide a short and direct response. 5.8. 